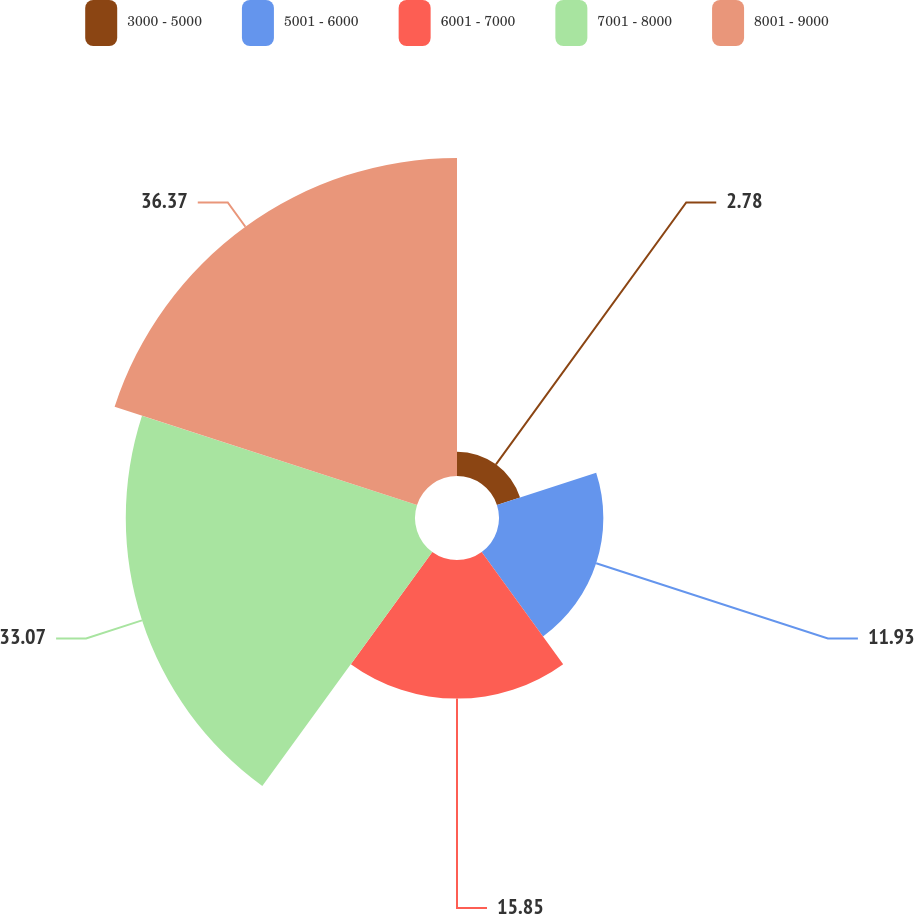Convert chart. <chart><loc_0><loc_0><loc_500><loc_500><pie_chart><fcel>3000 - 5000<fcel>5001 - 6000<fcel>6001 - 7000<fcel>7001 - 8000<fcel>8001 - 9000<nl><fcel>2.78%<fcel>11.93%<fcel>15.85%<fcel>33.07%<fcel>36.36%<nl></chart> 